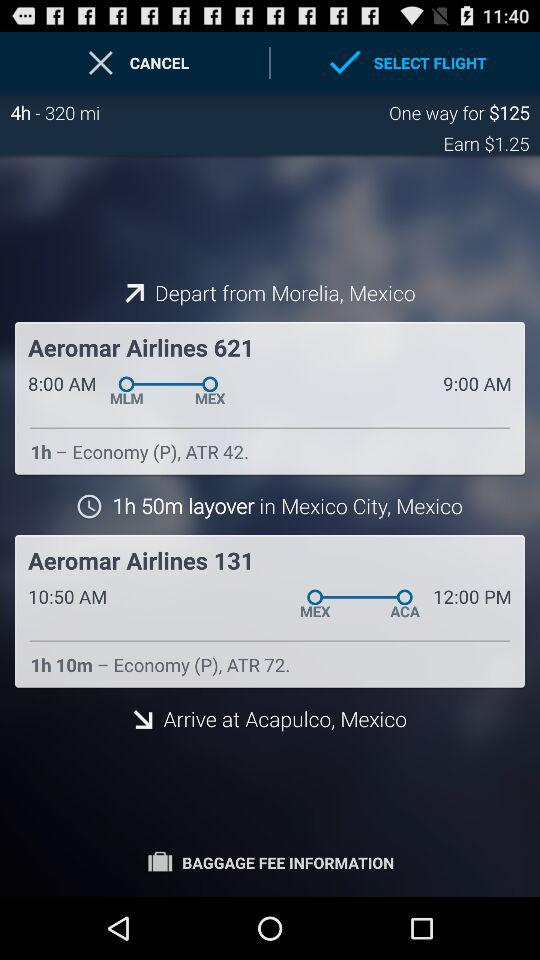What is the cost of the one-way journey? The cost is $125. 